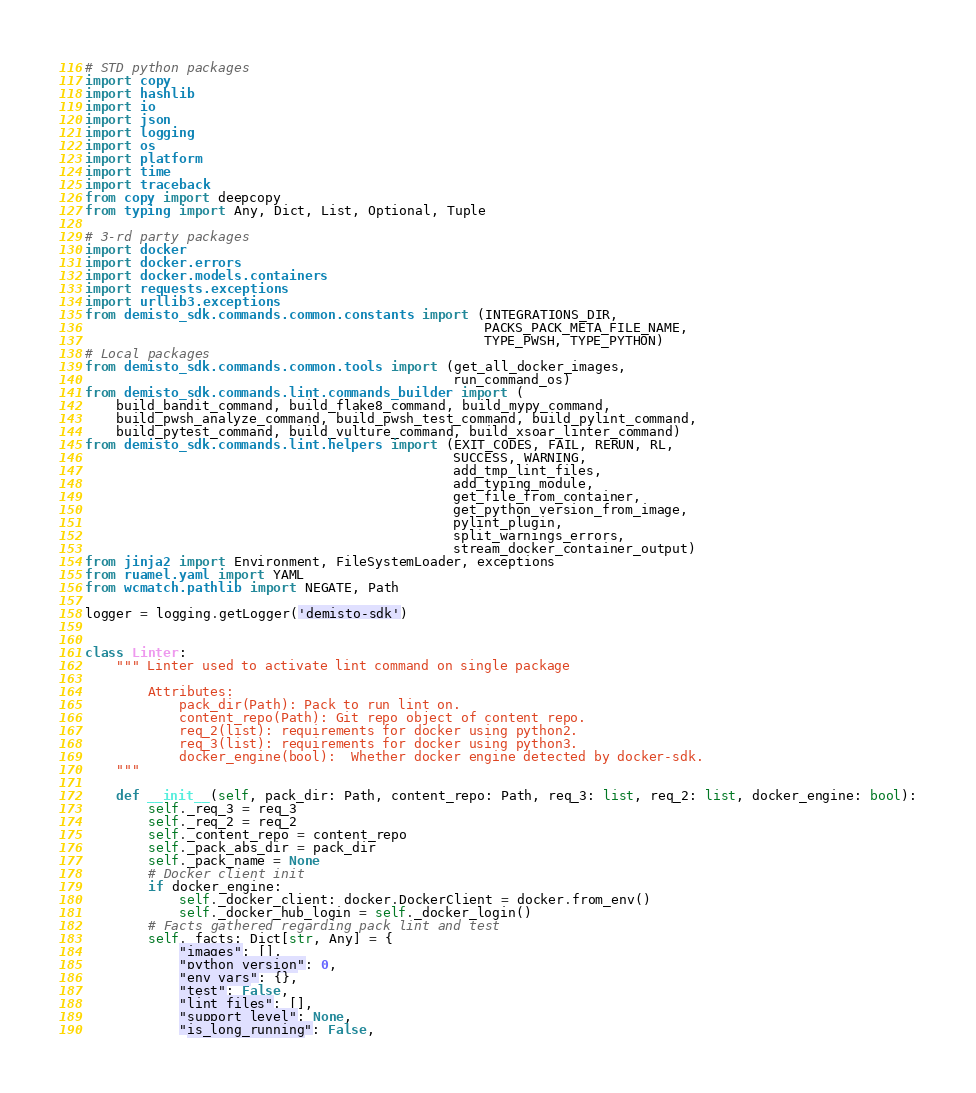<code> <loc_0><loc_0><loc_500><loc_500><_Python_># STD python packages
import copy
import hashlib
import io
import json
import logging
import os
import platform
import time
import traceback
from copy import deepcopy
from typing import Any, Dict, List, Optional, Tuple

# 3-rd party packages
import docker
import docker.errors
import docker.models.containers
import requests.exceptions
import urllib3.exceptions
from demisto_sdk.commands.common.constants import (INTEGRATIONS_DIR,
                                                   PACKS_PACK_META_FILE_NAME,
                                                   TYPE_PWSH, TYPE_PYTHON)
# Local packages
from demisto_sdk.commands.common.tools import (get_all_docker_images,
                                               run_command_os)
from demisto_sdk.commands.lint.commands_builder import (
    build_bandit_command, build_flake8_command, build_mypy_command,
    build_pwsh_analyze_command, build_pwsh_test_command, build_pylint_command,
    build_pytest_command, build_vulture_command, build_xsoar_linter_command)
from demisto_sdk.commands.lint.helpers import (EXIT_CODES, FAIL, RERUN, RL,
                                               SUCCESS, WARNING,
                                               add_tmp_lint_files,
                                               add_typing_module,
                                               get_file_from_container,
                                               get_python_version_from_image,
                                               pylint_plugin,
                                               split_warnings_errors,
                                               stream_docker_container_output)
from jinja2 import Environment, FileSystemLoader, exceptions
from ruamel.yaml import YAML
from wcmatch.pathlib import NEGATE, Path

logger = logging.getLogger('demisto-sdk')


class Linter:
    """ Linter used to activate lint command on single package

        Attributes:
            pack_dir(Path): Pack to run lint on.
            content_repo(Path): Git repo object of content repo.
            req_2(list): requirements for docker using python2.
            req_3(list): requirements for docker using python3.
            docker_engine(bool):  Whether docker engine detected by docker-sdk.
    """

    def __init__(self, pack_dir: Path, content_repo: Path, req_3: list, req_2: list, docker_engine: bool):
        self._req_3 = req_3
        self._req_2 = req_2
        self._content_repo = content_repo
        self._pack_abs_dir = pack_dir
        self._pack_name = None
        # Docker client init
        if docker_engine:
            self._docker_client: docker.DockerClient = docker.from_env()
            self._docker_hub_login = self._docker_login()
        # Facts gathered regarding pack lint and test
        self._facts: Dict[str, Any] = {
            "images": [],
            "python_version": 0,
            "env_vars": {},
            "test": False,
            "lint_files": [],
            "support_level": None,
            "is_long_running": False,</code> 